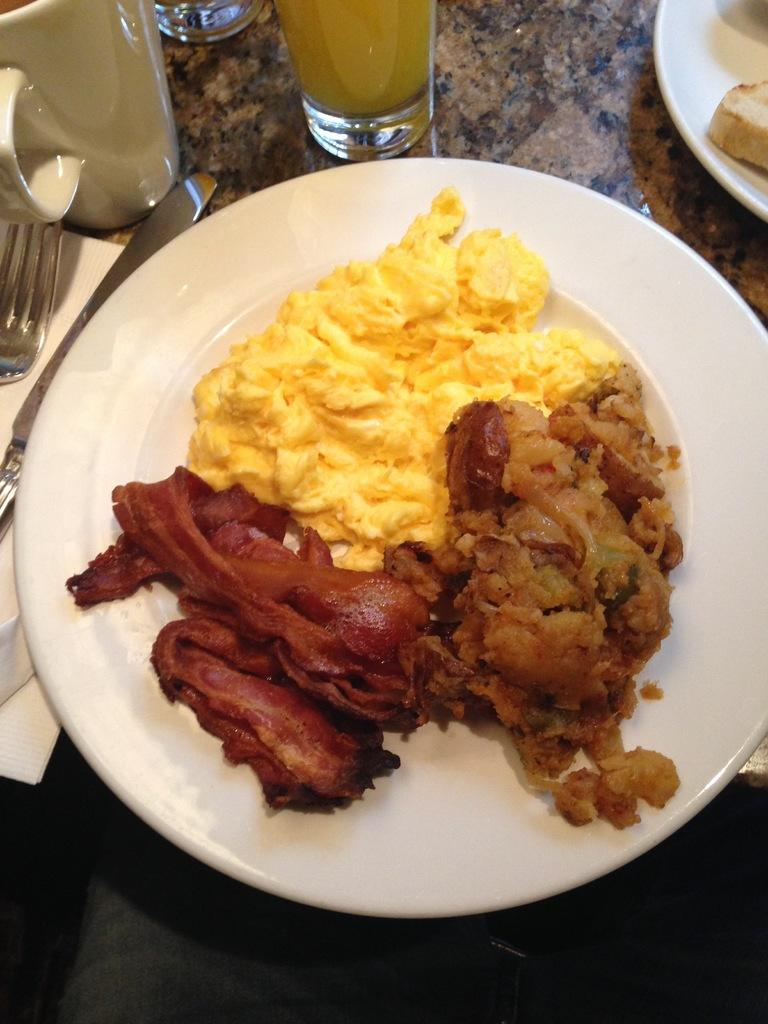What type of tableware can be seen in the image? There are plates, glasses, cups, and forks in the image. What else is present on the platform in the image? There is food and tissue paper on the platform. How many types of tableware are visible in the image? There are four types of tableware visible: plates, glasses, cups, and forks. Can you tell me how many hydrants are present in the image? There are no hydrants present in the image. What type of vase can be seen holding flowers in the image? There is no vase present in the image. 